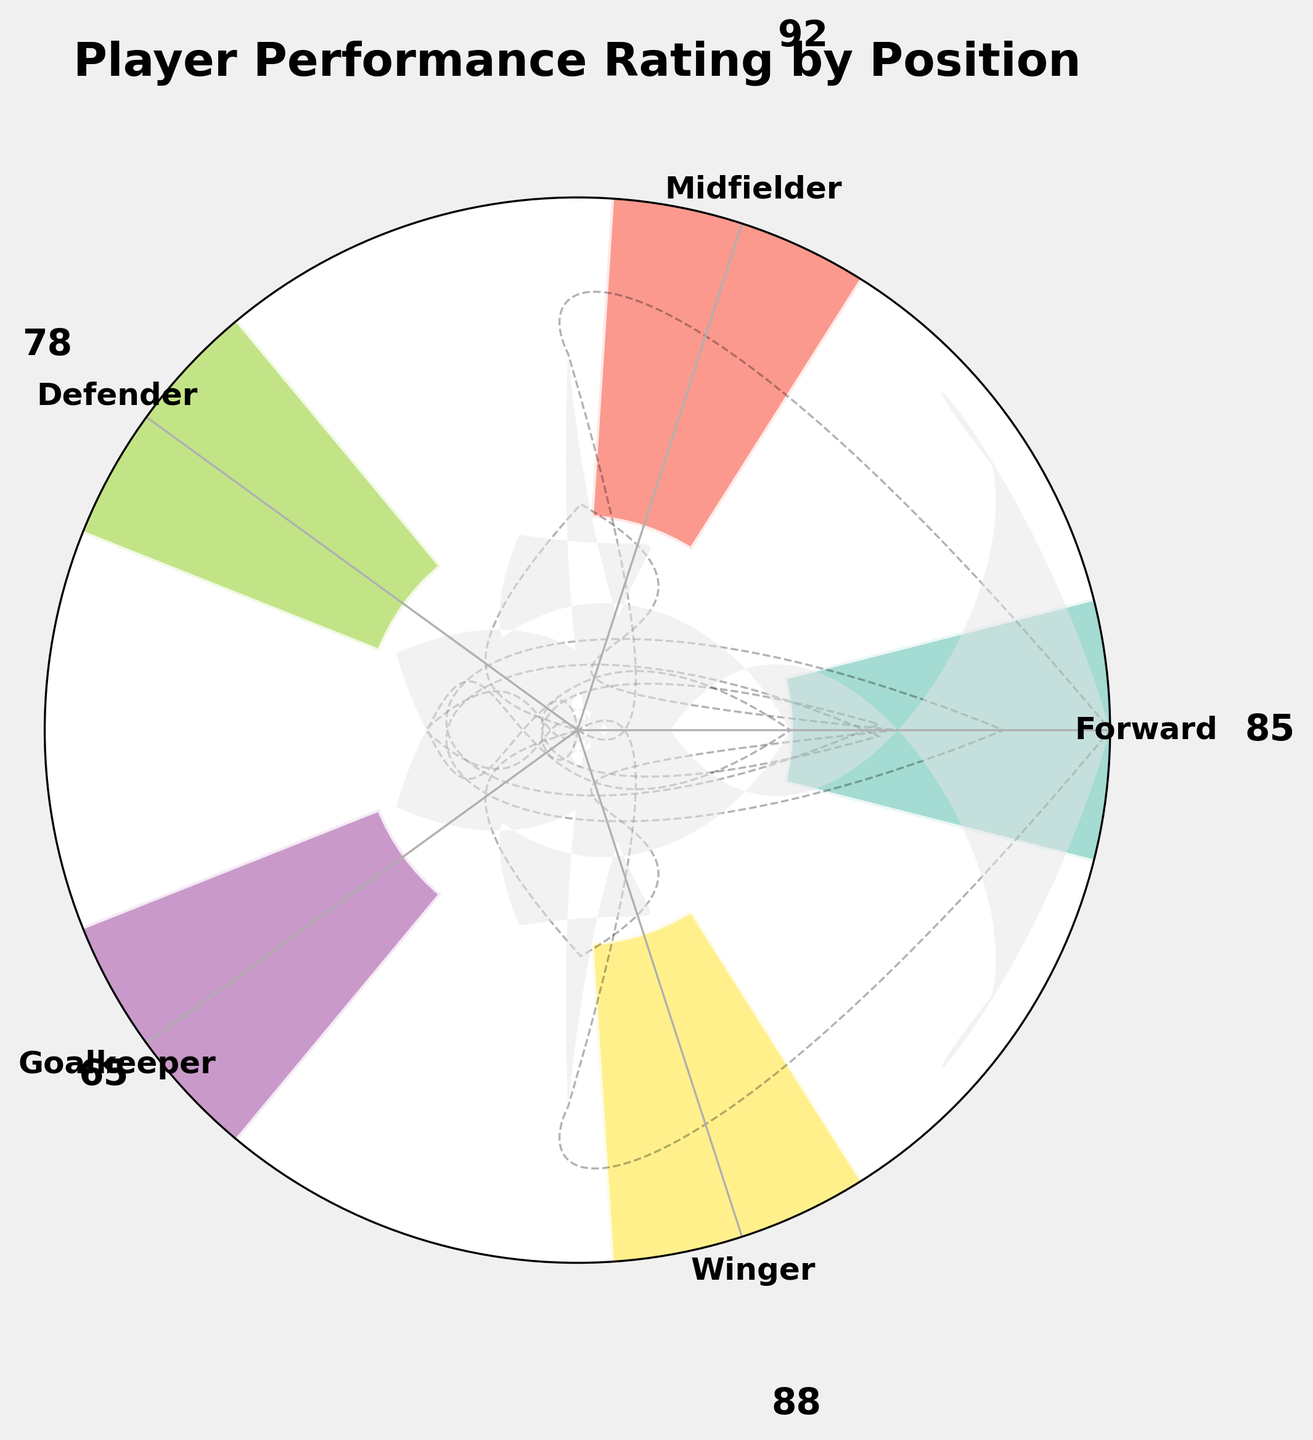What is the title of the chart? The title is displayed prominently at the top of the figure.
Answer: Player Performance Rating by Position Which position has the highest rating? By looking at the length of the bars, the Midfielder has the highest bar, indicating the highest rating.
Answer: Midfielder What is the rating for the Defender position? The rating value for the Defender position is displayed on the bar corresponding to Defender.
Answer: 78 What is the average rating of all positions? Sum the ratings of all positions (85 + 92 + 78 + 65 + 88) and divide by the number of positions (5). The average rating is (85 + 92 + 78 + 65 + 88)/5 = 81.6
Answer: 81.6 Which position has the lowest rating? By looking at the length of the bars, the Goalkeeper has the shortest bar, indicating the lowest rating.
Answer: Goalkeeper How many positions have a rating above 80? Identify the bars with ratings above 80. Forward (85), Midfielder (92), and Winger (88) all have ratings above 80.
Answer: 3 What is the difference in rating between the Winger and the Forward? Subtract the rating of Forward (85) from the rating of Winger (88): 88 - 85 = 3
Answer: 3 How much higher is the rating of the Midfielder compared to the Goalkeeper? Subtract the rating of Goalkeeper (65) from the rating of Midfielder (92): 92 - 65 = 27
Answer: 27 What are the positions shown in the chart? The positions are listed around the circular gauge.
Answer: Forward, Midfielder, Defender, Goalkeeper, Winger Is there any position with a rating between 70 and 80? Check the bars that fall within the 70-80 range. The Defender with a rating of 78 falls within this range.
Answer: Yes, Defender 